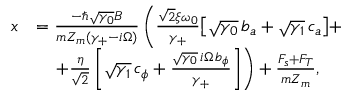<formula> <loc_0><loc_0><loc_500><loc_500>\begin{array} { r l } { x } & { = \frac { - \hslash \sqrt { \gamma _ { 0 } } B } { m Z _ { m } ( \gamma _ { + } - i \Omega ) } \left ( \frac { \sqrt { 2 } \xi \omega _ { 0 } } { \gamma _ { + } } \left [ \sqrt { \gamma _ { 0 } } \, b _ { a } + \sqrt { \gamma _ { 1 } } \, c _ { a } \right ] + } \\ & { \quad + \frac { \eta } { \sqrt { 2 } } \left [ \sqrt { \gamma _ { 1 } } \, c _ { \phi } + \frac { \sqrt { \gamma _ { 0 } } \, i \Omega \, b _ { \phi } } { \gamma _ { + } } \right ] \right ) + \frac { F _ { s } + F _ { T } } { m Z _ { m } } , } \end{array}</formula> 